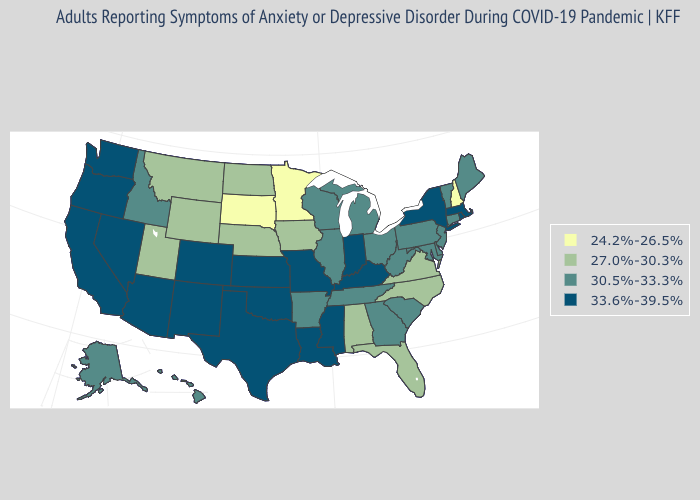What is the value of Utah?
Concise answer only. 27.0%-30.3%. Does the first symbol in the legend represent the smallest category?
Answer briefly. Yes. Does New Hampshire have the lowest value in the USA?
Keep it brief. Yes. Does Tennessee have a lower value than Mississippi?
Keep it brief. Yes. Among the states that border Alabama , which have the highest value?
Give a very brief answer. Mississippi. Name the states that have a value in the range 24.2%-26.5%?
Concise answer only. Minnesota, New Hampshire, South Dakota. What is the lowest value in states that border New York?
Answer briefly. 30.5%-33.3%. What is the value of Alaska?
Short answer required. 30.5%-33.3%. What is the value of Michigan?
Give a very brief answer. 30.5%-33.3%. What is the value of Rhode Island?
Answer briefly. 33.6%-39.5%. What is the value of Kentucky?
Keep it brief. 33.6%-39.5%. Name the states that have a value in the range 30.5%-33.3%?
Be succinct. Alaska, Arkansas, Connecticut, Delaware, Georgia, Hawaii, Idaho, Illinois, Maine, Maryland, Michigan, New Jersey, Ohio, Pennsylvania, South Carolina, Tennessee, Vermont, West Virginia, Wisconsin. What is the value of Hawaii?
Give a very brief answer. 30.5%-33.3%. Does Arkansas have a higher value than Virginia?
Short answer required. Yes. How many symbols are there in the legend?
Write a very short answer. 4. 